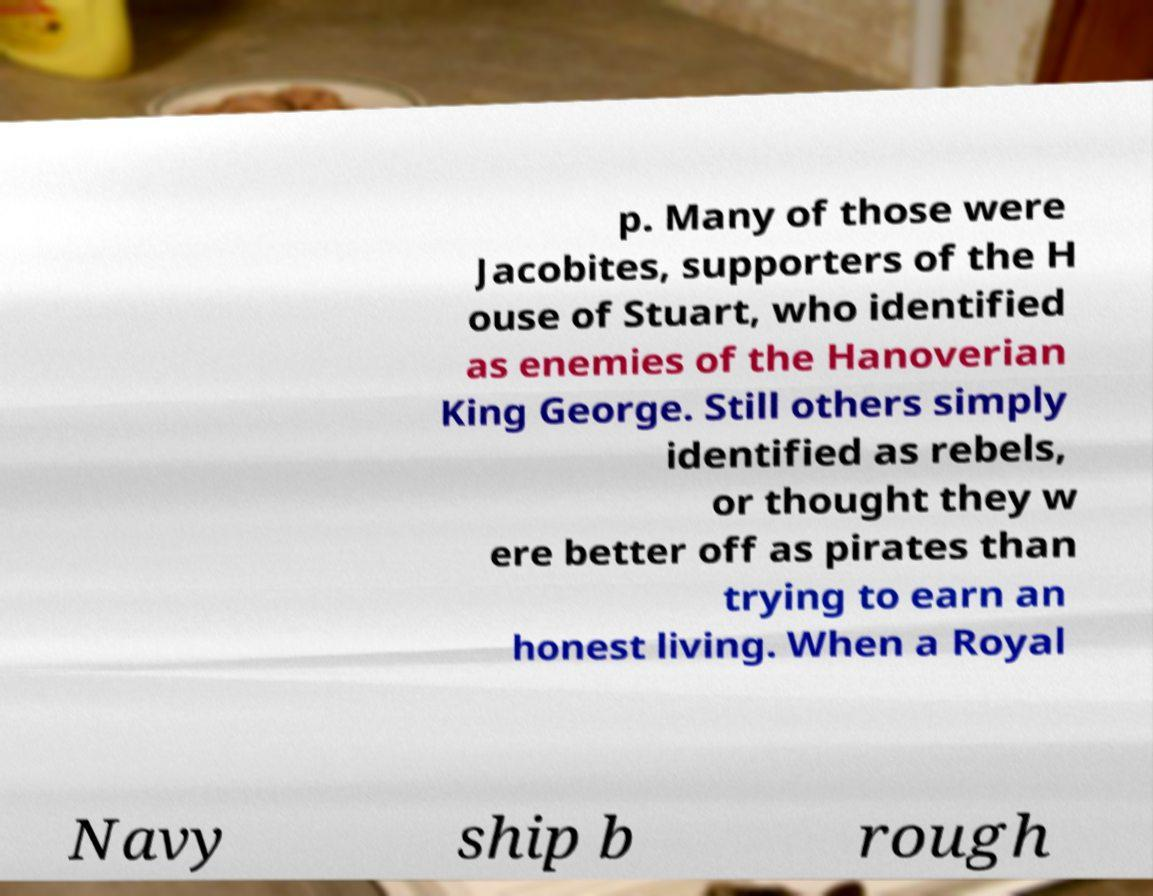Please identify and transcribe the text found in this image. p. Many of those were Jacobites, supporters of the H ouse of Stuart, who identified as enemies of the Hanoverian King George. Still others simply identified as rebels, or thought they w ere better off as pirates than trying to earn an honest living. When a Royal Navy ship b rough 